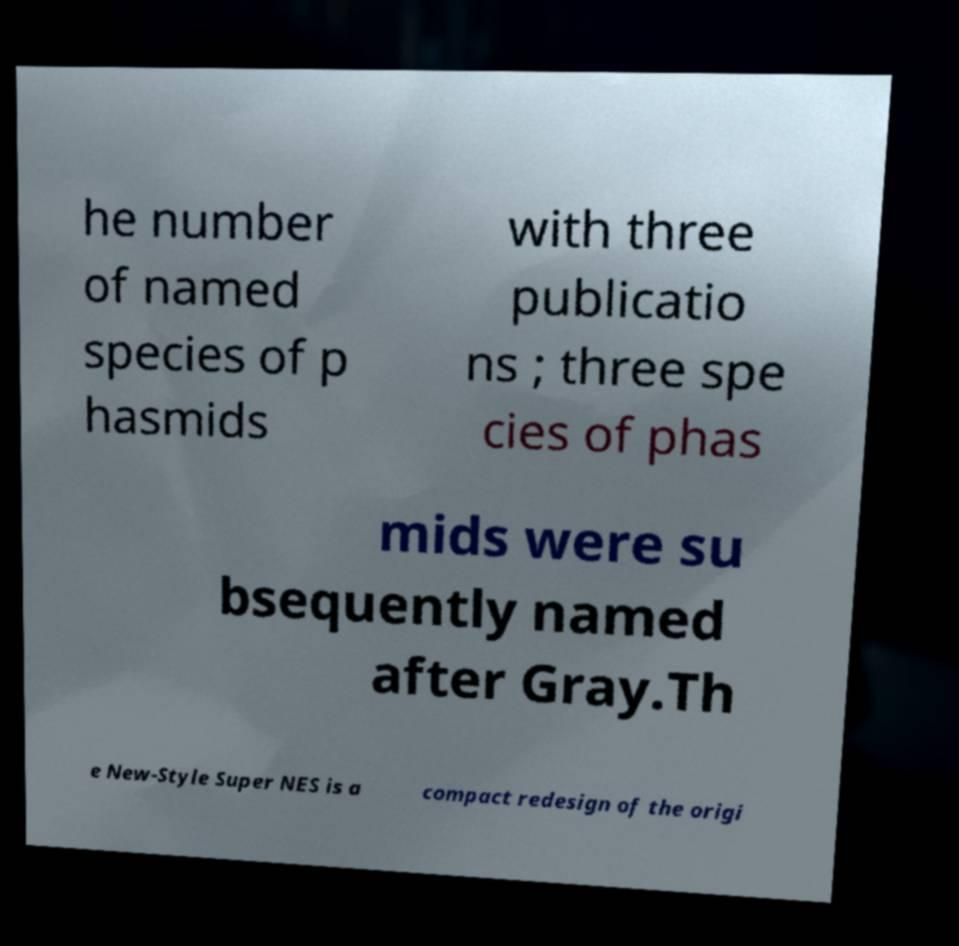What messages or text are displayed in this image? I need them in a readable, typed format. he number of named species of p hasmids with three publicatio ns ; three spe cies of phas mids were su bsequently named after Gray.Th e New-Style Super NES is a compact redesign of the origi 